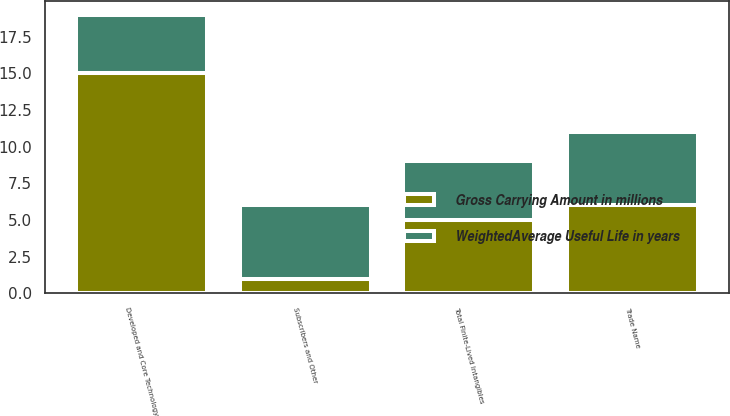Convert chart. <chart><loc_0><loc_0><loc_500><loc_500><stacked_bar_chart><ecel><fcel>Developed and Core Technology<fcel>Trade Name<fcel>Subscribers and Other<fcel>Total Finite-Lived Intangibles<nl><fcel>Gross Carrying Amount in millions<fcel>15<fcel>6<fcel>1<fcel>5<nl><fcel>WeightedAverage Useful Life in years<fcel>4<fcel>5<fcel>5<fcel>4<nl></chart> 